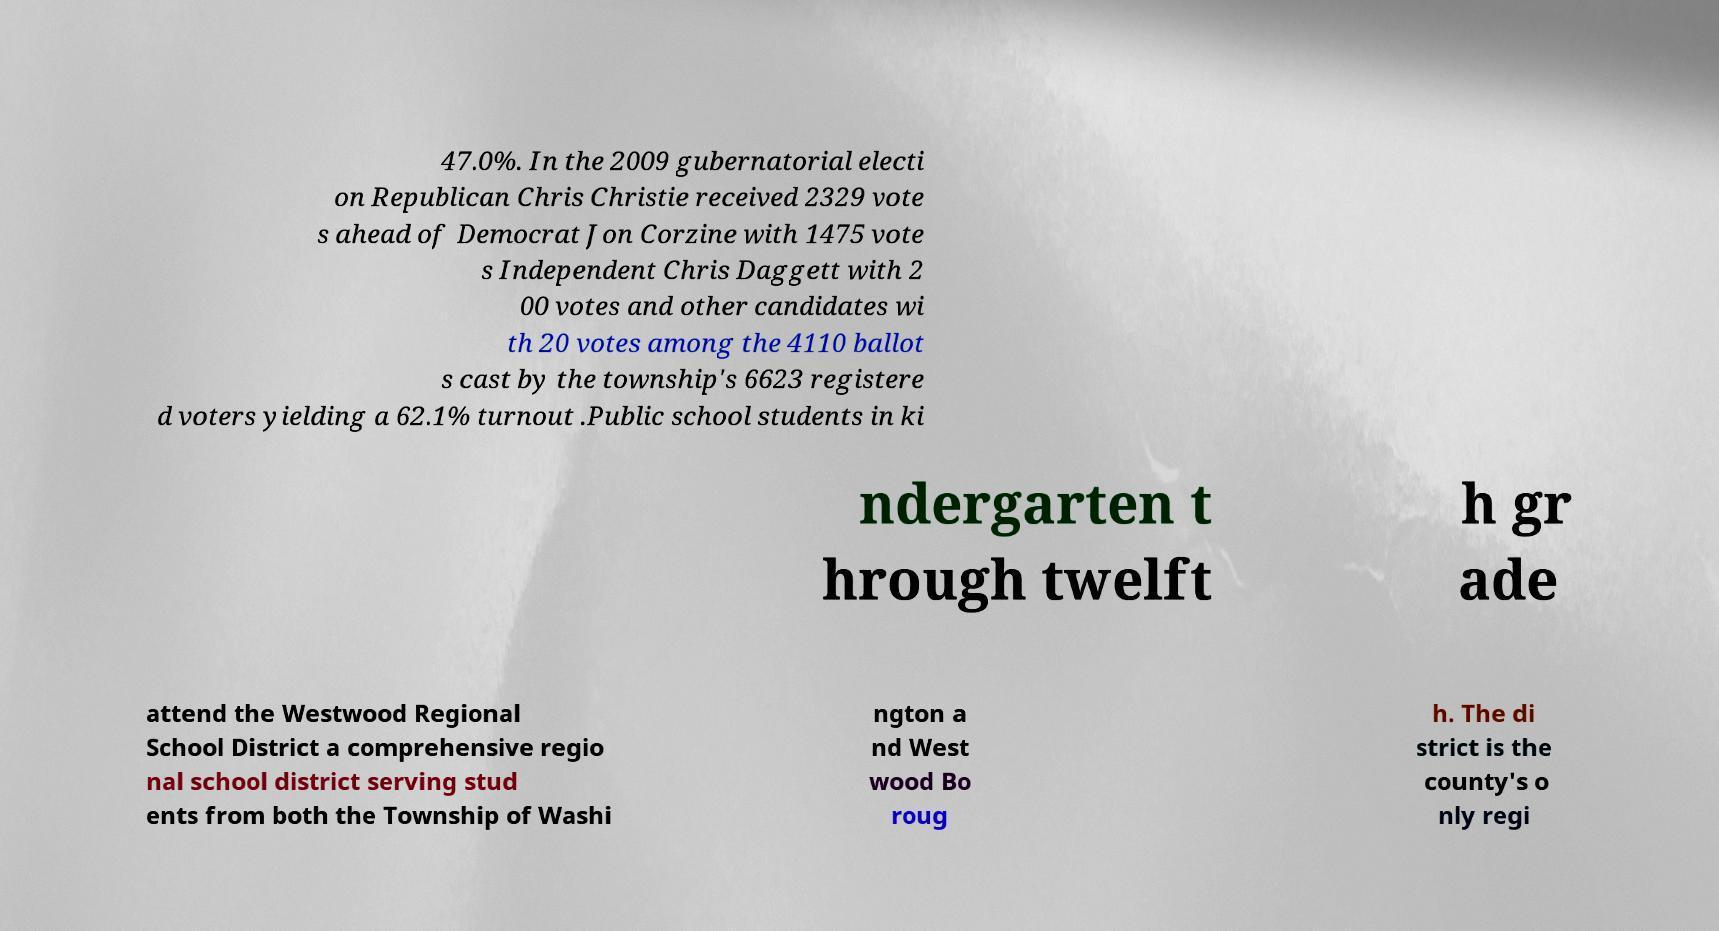Can you accurately transcribe the text from the provided image for me? 47.0%. In the 2009 gubernatorial electi on Republican Chris Christie received 2329 vote s ahead of Democrat Jon Corzine with 1475 vote s Independent Chris Daggett with 2 00 votes and other candidates wi th 20 votes among the 4110 ballot s cast by the township's 6623 registere d voters yielding a 62.1% turnout .Public school students in ki ndergarten t hrough twelft h gr ade attend the Westwood Regional School District a comprehensive regio nal school district serving stud ents from both the Township of Washi ngton a nd West wood Bo roug h. The di strict is the county's o nly regi 